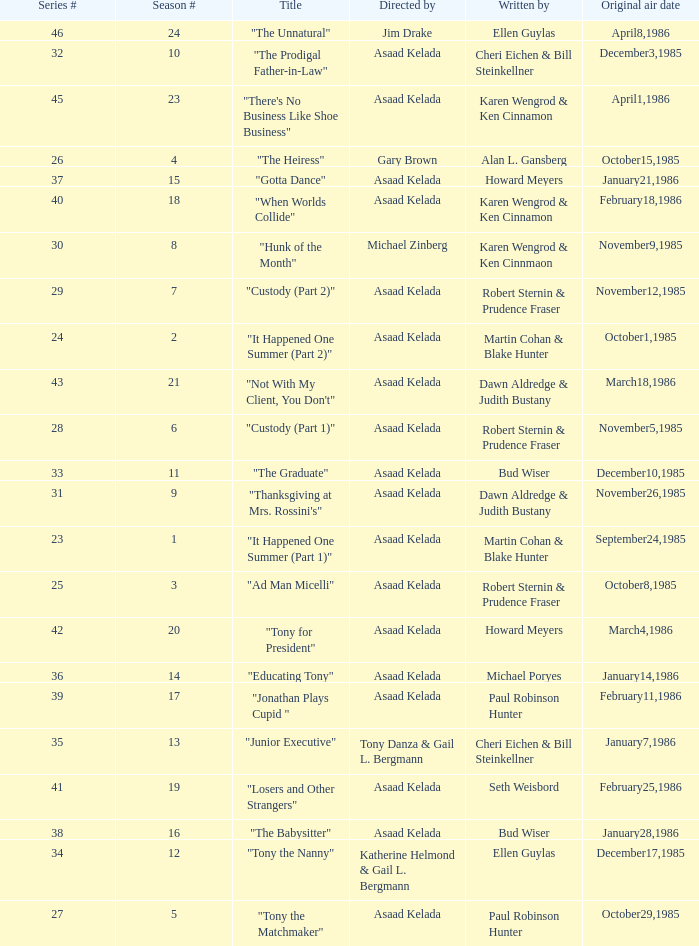Who were the authors of series episode #25? Robert Sternin & Prudence Fraser. 